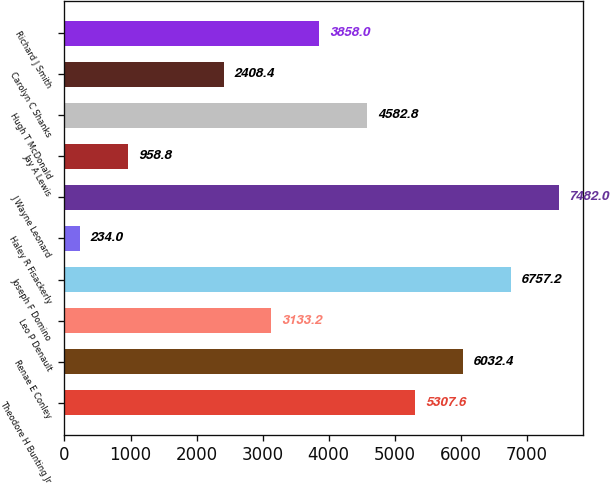Convert chart to OTSL. <chart><loc_0><loc_0><loc_500><loc_500><bar_chart><fcel>Theodore H Bunting Jr<fcel>Renae E Conley<fcel>Leo P Denault<fcel>Joseph F Domino<fcel>Haley R Fisackerly<fcel>J Wayne Leonard<fcel>Jay A Lewis<fcel>Hugh T McDonald<fcel>Carolyn C Shanks<fcel>Richard J Smith<nl><fcel>5307.6<fcel>6032.4<fcel>3133.2<fcel>6757.2<fcel>234<fcel>7482<fcel>958.8<fcel>4582.8<fcel>2408.4<fcel>3858<nl></chart> 